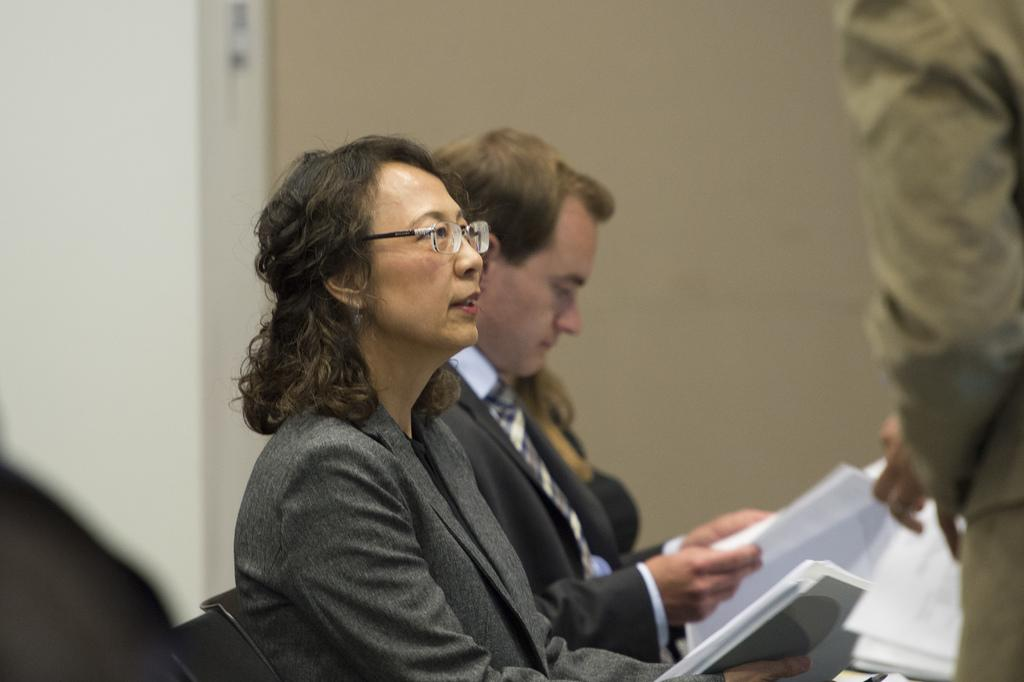How many persons are in the image? There are persons in the image. What are the persons doing in the image? The persons are sitting on chairs and holding papers in their hands. Is there anyone standing in the image? Yes, there is a person standing on the right side of the image. What can be seen in the background of the image? There is a wall in the background of the image. What type of unit can be seen in the image? There is no unit present in the image. Did the earthquake cause any damage to the persons or their surroundings in the image? There is no mention of an earthquake or any damage in the image. 